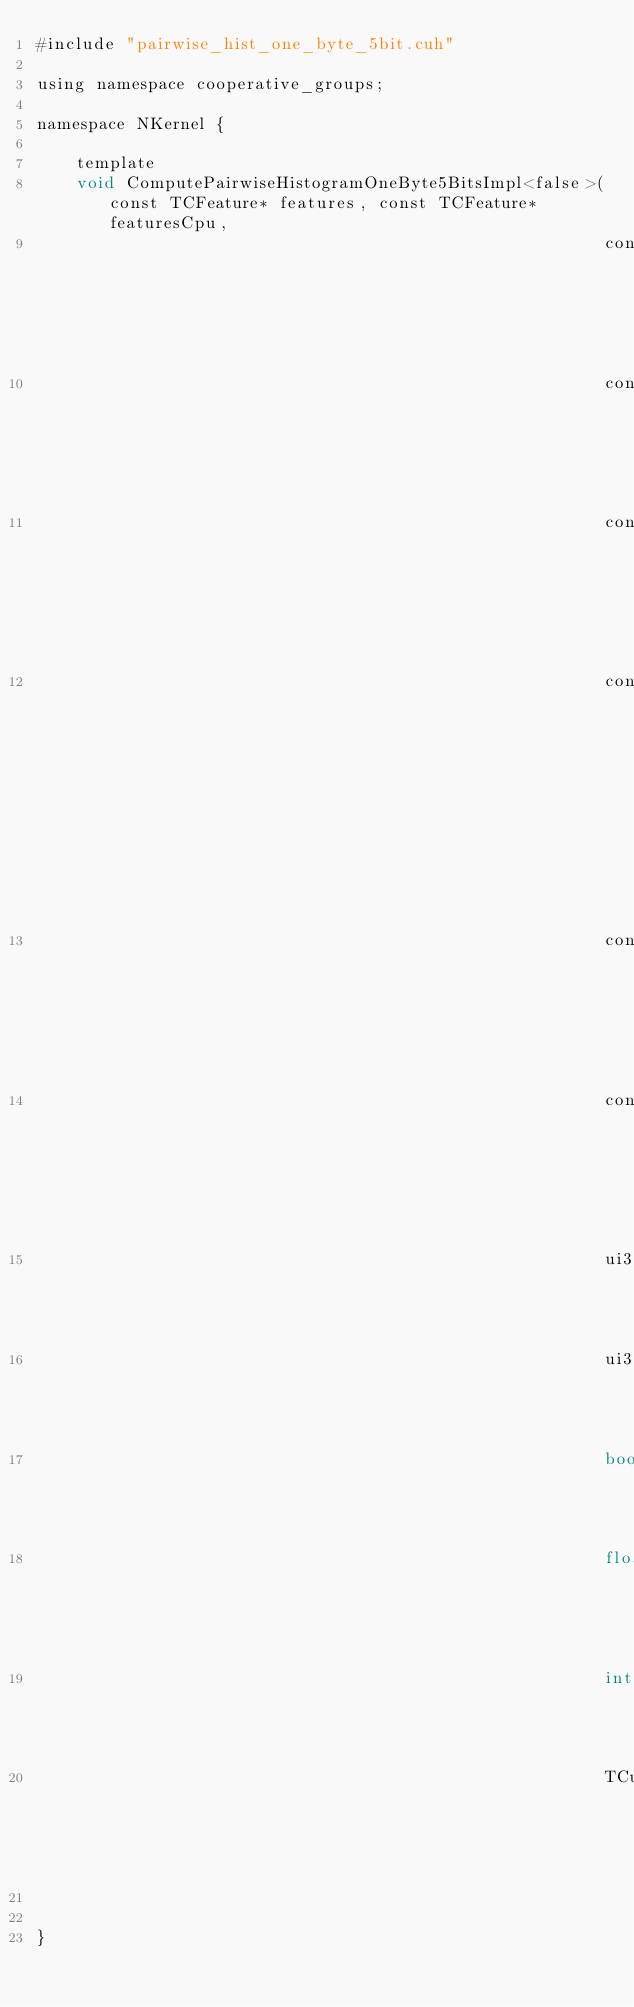<code> <loc_0><loc_0><loc_500><loc_500><_Cuda_>#include "pairwise_hist_one_byte_5bit.cuh"

using namespace cooperative_groups;

namespace NKernel {

    template
    void ComputePairwiseHistogramOneByte5BitsImpl<false>(const TCFeature* features, const TCFeature* featuresCpu,
                                                         const ui32 featureCount,
                                                         const ui32 fiveBitsFeatureCount,
                                                         const ui32* compressedIndex,
                                                         const uint2* pairs, ui32 pairCount,
                                                         const float* weight,
                                                         const TDataPartition* partition,
                                                         ui32 partCount,
                                                         ui32 histLineSize,
                                                         bool fullPass,
                                                         float* histogram,
                                                         int parallelStreams,
                                                         TCudaStream stream);


}
</code> 